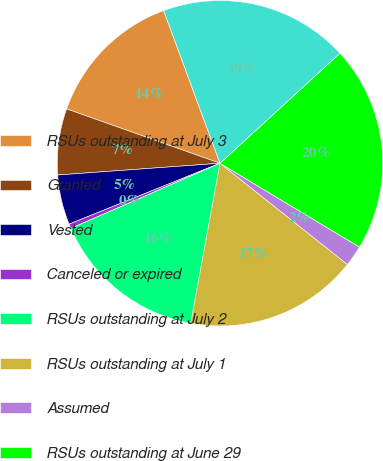Convert chart to OTSL. <chart><loc_0><loc_0><loc_500><loc_500><pie_chart><fcel>RSUs outstanding at July 3<fcel>Granted<fcel>Vested<fcel>Canceled or expired<fcel>RSUs outstanding at July 2<fcel>RSUs outstanding at July 1<fcel>Assumed<fcel>RSUs outstanding at June 29<fcel>Expected to vest after June 29<nl><fcel>13.95%<fcel>6.57%<fcel>4.95%<fcel>0.45%<fcel>15.57%<fcel>17.19%<fcel>2.07%<fcel>20.43%<fcel>18.81%<nl></chart> 